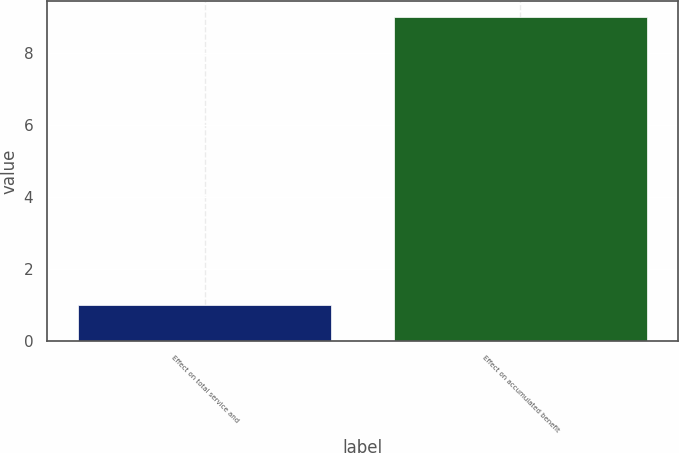Convert chart to OTSL. <chart><loc_0><loc_0><loc_500><loc_500><bar_chart><fcel>Effect on total service and<fcel>Effect on accumulated benefit<nl><fcel>1<fcel>9<nl></chart> 